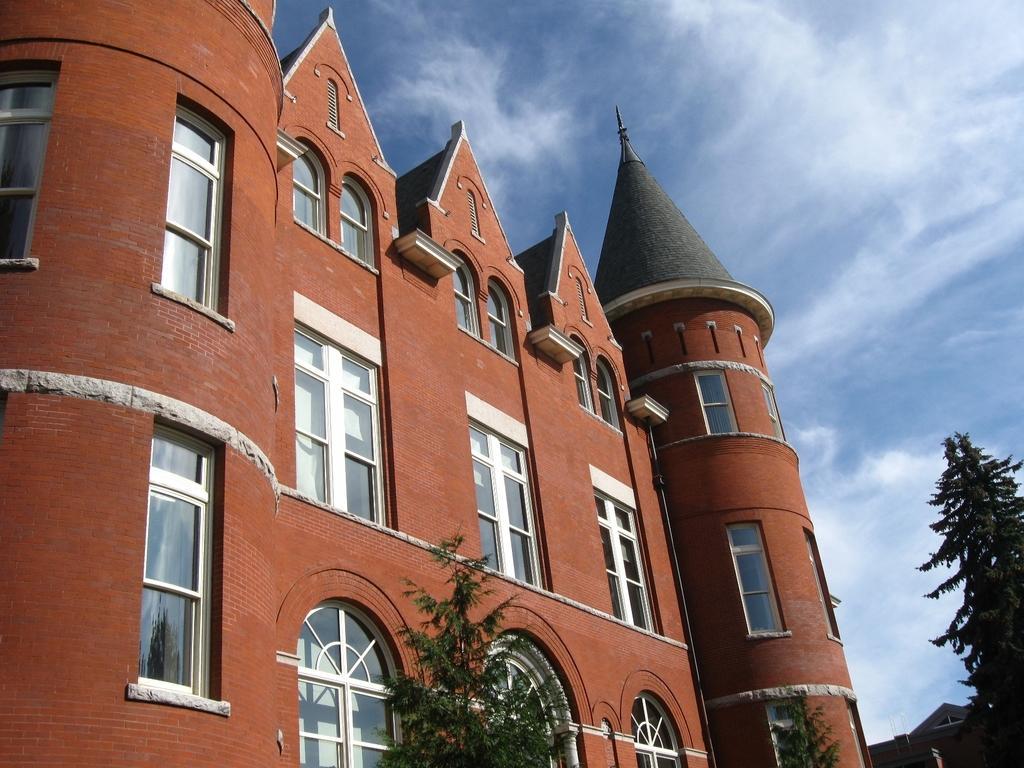How would you summarize this image in a sentence or two? On the left there is a building and we can see windows and a pipe on the wall. At the bottom we can see trees and in the background there is a building and clouds in the sky. 